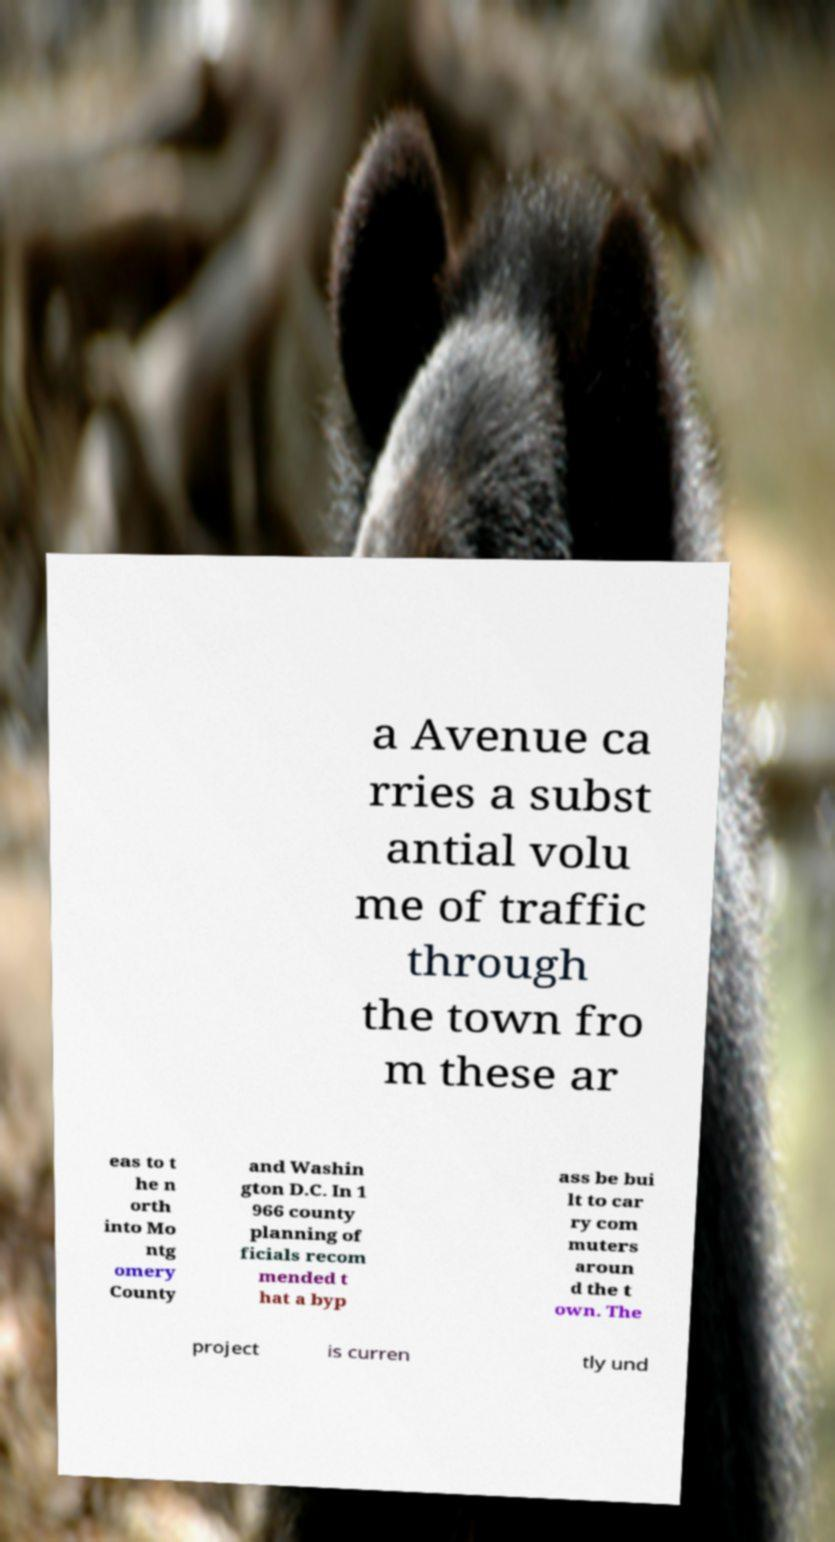What messages or text are displayed in this image? I need them in a readable, typed format. a Avenue ca rries a subst antial volu me of traffic through the town fro m these ar eas to t he n orth into Mo ntg omery County and Washin gton D.C. In 1 966 county planning of ficials recom mended t hat a byp ass be bui lt to car ry com muters aroun d the t own. The project is curren tly und 